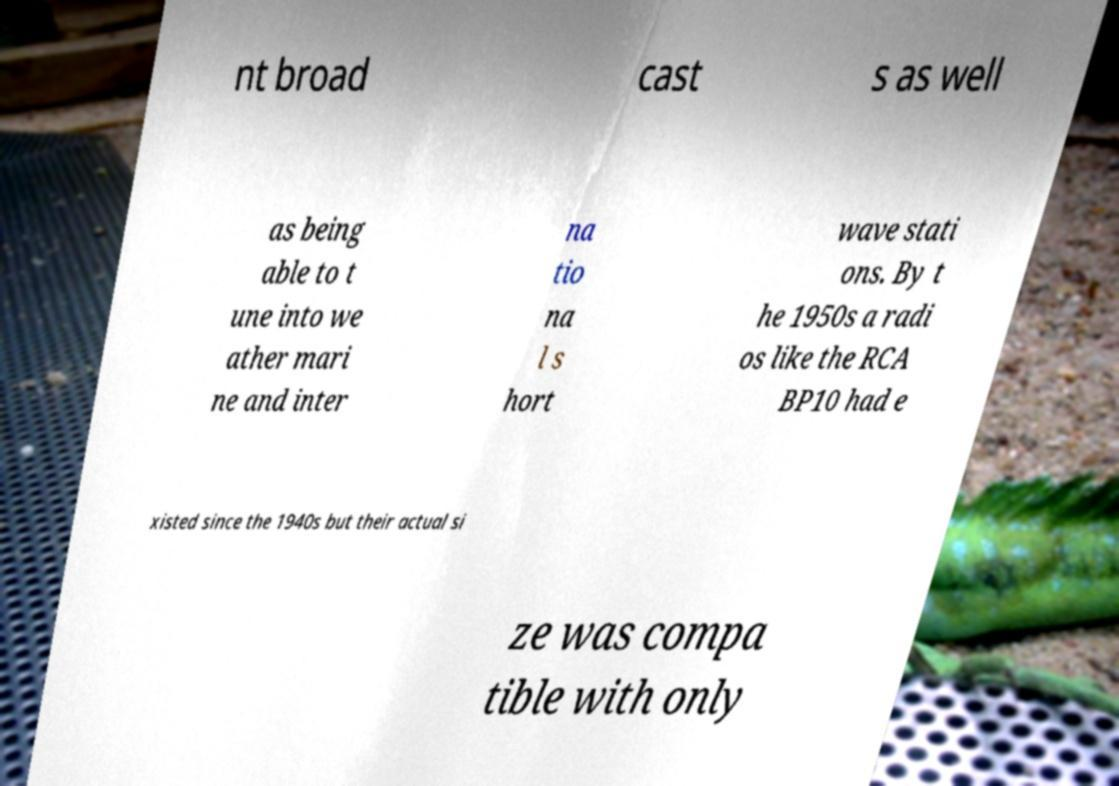What messages or text are displayed in this image? I need them in a readable, typed format. nt broad cast s as well as being able to t une into we ather mari ne and inter na tio na l s hort wave stati ons. By t he 1950s a radi os like the RCA BP10 had e xisted since the 1940s but their actual si ze was compa tible with only 